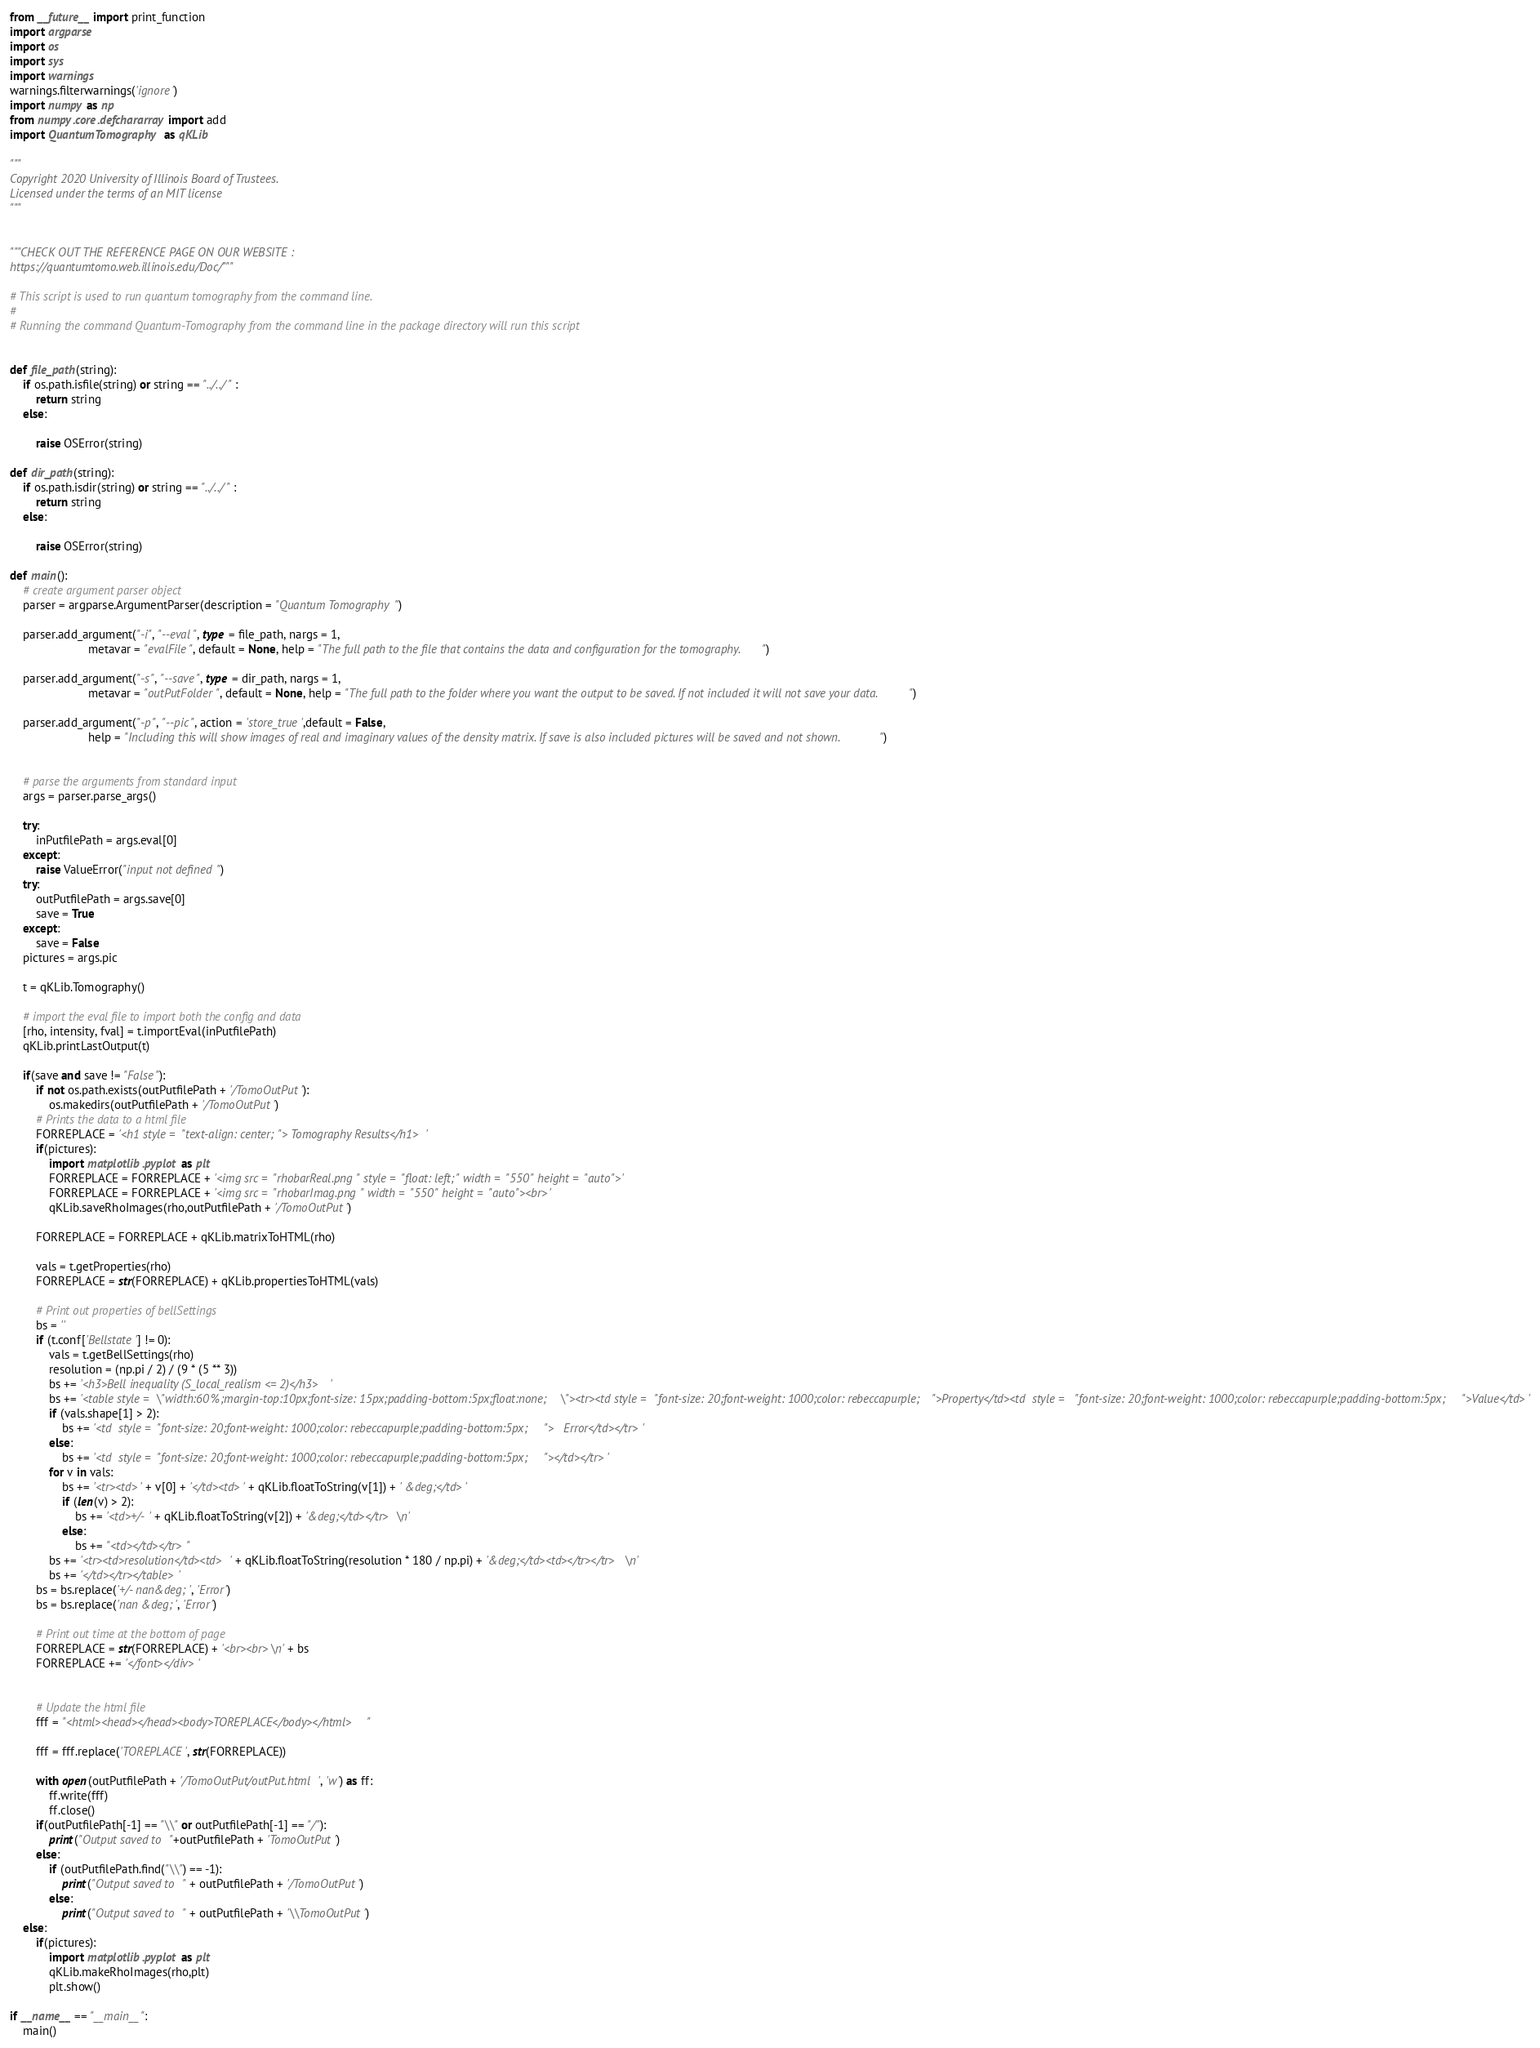Convert code to text. <code><loc_0><loc_0><loc_500><loc_500><_Python_>from __future__ import print_function
import argparse
import os
import sys
import warnings
warnings.filterwarnings('ignore')
import numpy as np
from numpy.core.defchararray import add
import QuantumTomography as qKLib

"""
Copyright 2020 University of Illinois Board of Trustees.
Licensed under the terms of an MIT license
"""


"""CHECK OUT THE REFERENCE PAGE ON OUR WEBSITE :
https://quantumtomo.web.illinois.edu/Doc/"""

# This script is used to run quantum tomography from the command line.
#
# Running the command Quantum-Tomography from the command line in the package directory will run this script


def file_path(string):
    if os.path.isfile(string) or string == "../../" :
        return string
    else:

        raise OSError(string)

def dir_path(string):
    if os.path.isdir(string) or string == "../../" :
        return string
    else:

        raise OSError(string)

def main():
    # create argument parser object
    parser = argparse.ArgumentParser(description = "Quantum Tomography")

    parser.add_argument("-i", "--eval", type = file_path, nargs = 1,
                        metavar = "evalFile", default = None, help = "The full path to the file that contains the data and configuration for the tomography.")

    parser.add_argument("-s", "--save", type = dir_path, nargs = 1,
                        metavar = "outPutFolder", default = None, help = "The full path to the folder where you want the output to be saved. If not included it will not save your data.")

    parser.add_argument("-p", "--pic", action = 'store_true',default = False,
                        help = "Including this will show images of real and imaginary values of the density matrix. If save is also included pictures will be saved and not shown.")


    # parse the arguments from standard input
    args = parser.parse_args()

    try:
        inPutfilePath = args.eval[0]
    except:
        raise ValueError("input not defined")
    try:
        outPutfilePath = args.save[0]
        save = True
    except:
        save = False
    pictures = args.pic

    t = qKLib.Tomography()

    # import the eval file to import both the config and data
    [rho, intensity, fval] = t.importEval(inPutfilePath)
    qKLib.printLastOutput(t)

    if(save and save != "False"):
        if not os.path.exists(outPutfilePath + '/TomoOutPut'):
            os.makedirs(outPutfilePath + '/TomoOutPut')
        # Prints the data to a html file
        FORREPLACE = '<h1 style = "text-align: center;"> Tomography Results</h1>'
        if(pictures):
            import matplotlib.pyplot as plt
            FORREPLACE = FORREPLACE + '<img src = "rhobarReal.png" style = "float: left;" width = "550" height = "auto">'
            FORREPLACE = FORREPLACE + '<img src = "rhobarImag.png" width = "550" height = "auto"><br>'
            qKLib.saveRhoImages(rho,outPutfilePath + '/TomoOutPut')

        FORREPLACE = FORREPLACE + qKLib.matrixToHTML(rho)

        vals = t.getProperties(rho)
        FORREPLACE = str(FORREPLACE) + qKLib.propertiesToHTML(vals)

        # Print out properties of bellSettings
        bs = ''
        if (t.conf['Bellstate'] != 0):
            vals = t.getBellSettings(rho)
            resolution = (np.pi / 2) / (9 * (5 ** 3))
            bs += '<h3>Bell inequality (S_local_realism <= 2)</h3>'
            bs += '<table style = \"width:60%;margin-top:10px;font-size: 15px;padding-bottom:5px;float:none;\"><tr><td style = "font-size: 20;font-weight: 1000;color: rebeccapurple;">Property</td><td  style = "font-size: 20;font-weight: 1000;color: rebeccapurple;padding-bottom:5px;">Value</td>'
            if (vals.shape[1] > 2):
                bs += '<td  style = "font-size: 20;font-weight: 1000;color: rebeccapurple;padding-bottom:5px;">   Error</td></tr>'
            else:
                bs += '<td  style = "font-size: 20;font-weight: 1000;color: rebeccapurple;padding-bottom:5px;"></td></tr>'
            for v in vals:
                bs += '<tr><td>' + v[0] + '</td><td>' + qKLib.floatToString(v[1]) + ' &deg;</td>'
                if (len(v) > 2):
                    bs += '<td>+/- ' + qKLib.floatToString(v[2]) + '&deg;</td></tr> \n'
                else:
                    bs += "<td></td></tr>"
            bs += '<tr><td>resolution</td><td>' + qKLib.floatToString(resolution * 180 / np.pi) + '&deg;</td><td></tr></tr> \n'
            bs += '</td></tr></table>'
        bs = bs.replace('+/- nan&deg;', 'Error')
        bs = bs.replace('nan &deg;', 'Error')

        # Print out time at the bottom of page
        FORREPLACE = str(FORREPLACE) + '<br><br>\n' + bs
        FORREPLACE += '</font></div>'


        # Update the html file
        fff = "<html><head></head><body>TOREPLACE</body></html>"

        fff = fff.replace('TOREPLACE', str(FORREPLACE))

        with open(outPutfilePath + '/TomoOutPut/outPut.html', 'w') as ff:
            ff.write(fff)
            ff.close()
        if(outPutfilePath[-1] == "\\" or outPutfilePath[-1] == "/"):
            print("Output saved to "+outPutfilePath + 'TomoOutPut')
        else:
            if (outPutfilePath.find("\\") == -1):
                print("Output saved to " + outPutfilePath + '/TomoOutPut')
            else:
                print("Output saved to " + outPutfilePath + '\\TomoOutPut')
    else:
        if(pictures):
            import matplotlib.pyplot as plt
            qKLib.makeRhoImages(rho,plt)
            plt.show()

if __name__ == "__main__":
    main()
</code> 